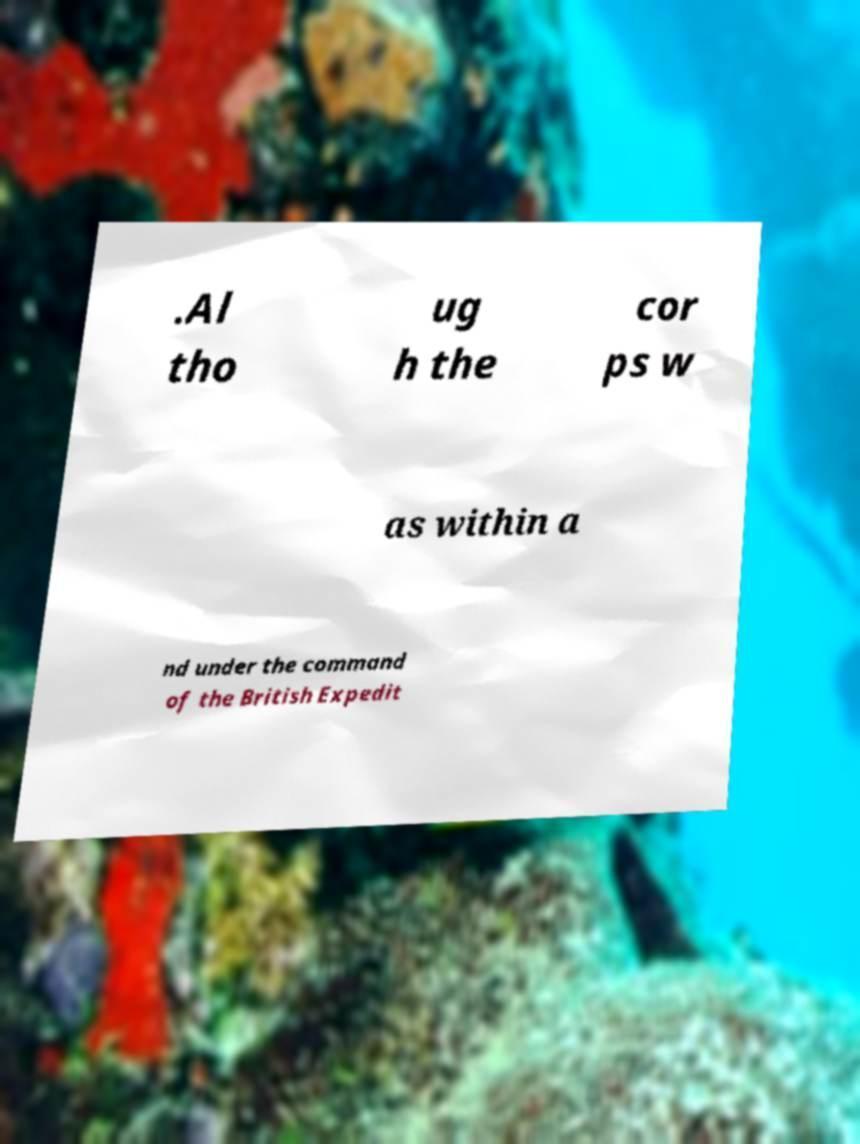There's text embedded in this image that I need extracted. Can you transcribe it verbatim? .Al tho ug h the cor ps w as within a nd under the command of the British Expedit 